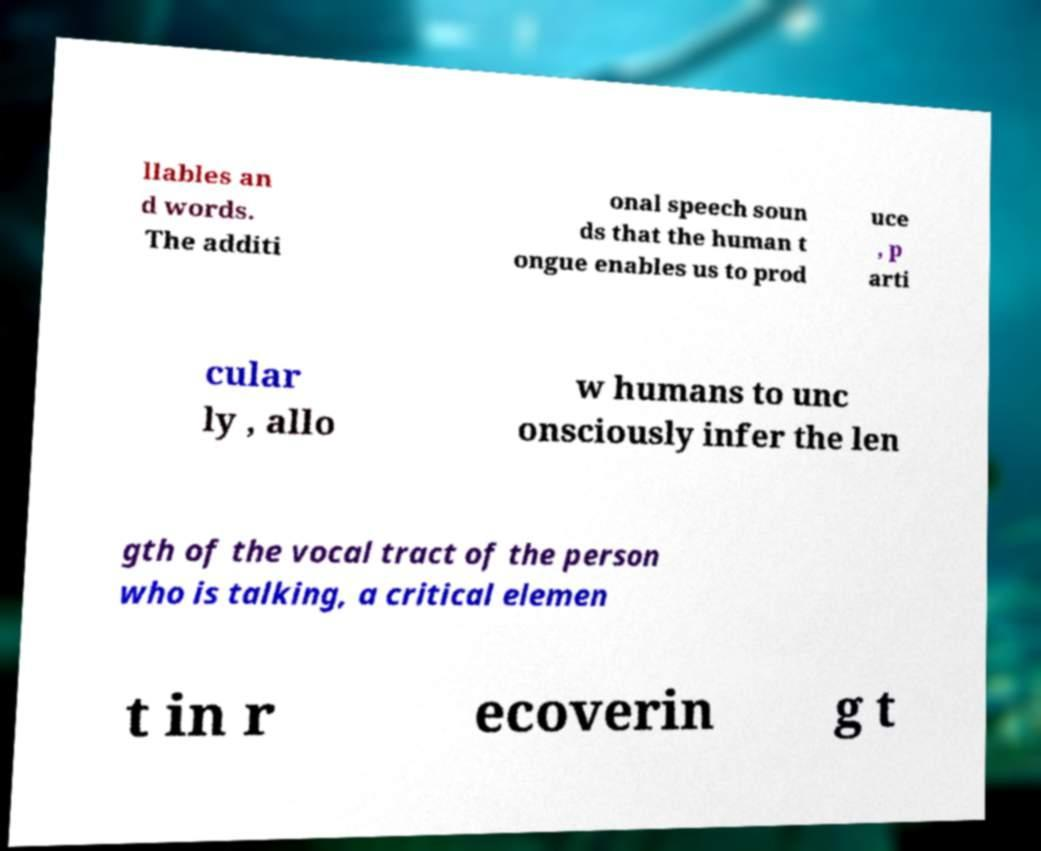I need the written content from this picture converted into text. Can you do that? llables an d words. The additi onal speech soun ds that the human t ongue enables us to prod uce , p arti cular ly , allo w humans to unc onsciously infer the len gth of the vocal tract of the person who is talking, a critical elemen t in r ecoverin g t 